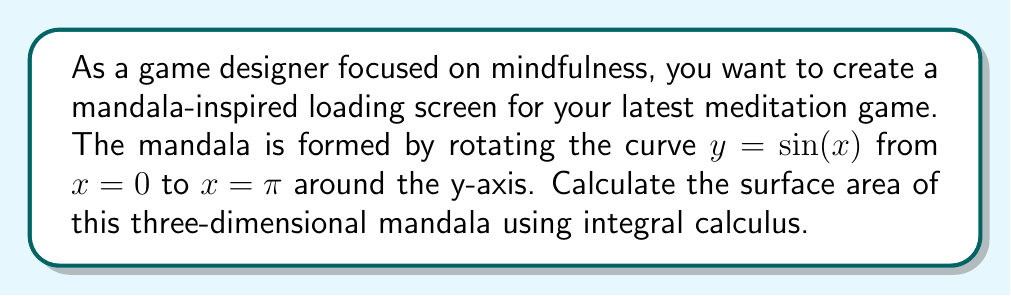Help me with this question. To solve this problem, we'll use the surface area formula for a surface of revolution:

$$ A = 2\pi \int_a^b f(x) \sqrt{1 + [f'(x)]^2} dx $$

Where $f(x) = \sin(x)$ is the function being rotated, and the limits of integration are from $a = 0$ to $b = \pi$.

Steps:
1) First, we need to find $f'(x)$:
   $f'(x) = \cos(x)$

2) Now we can set up our integral:
   $$ A = 2\pi \int_0^\pi \sin(x) \sqrt{1 + [\cos(x)]^2} dx $$

3) Simplify the expression under the square root:
   $$ A = 2\pi \int_0^\pi \sin(x) \sqrt{1 + \cos^2(x)} dx $$
   $$ A = 2\pi \int_0^\pi \sin(x) \sqrt{2 - \sin^2(x)} dx $$

4) This integral doesn't have an elementary antiderivative. We need to use numerical integration or special functions to evaluate it.

5) Using a computer algebra system or numerical integration, we can evaluate this integral:
   $$ \int_0^\pi \sin(x) \sqrt{2 - \sin^2(x)} dx \approx 2.75407 $$

6) Multiply by $2\pi$:
   $$ A = 2\pi * 2.75407 \approx 17.31564 $$

Thus, the surface area of the mandala is approximately 17.31564 square units.
Answer: The surface area of the mandala is approximately 17.32 square units. 